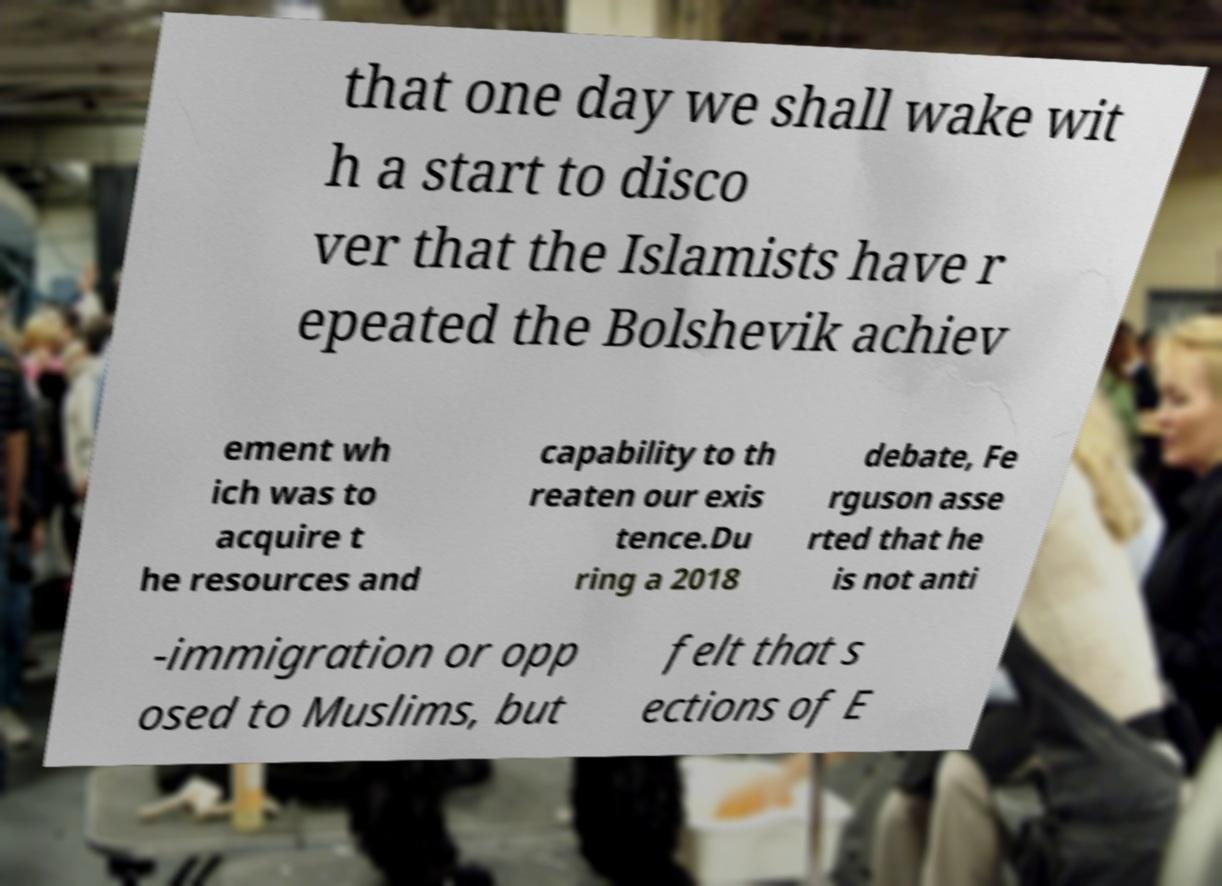Can you read and provide the text displayed in the image?This photo seems to have some interesting text. Can you extract and type it out for me? that one day we shall wake wit h a start to disco ver that the Islamists have r epeated the Bolshevik achiev ement wh ich was to acquire t he resources and capability to th reaten our exis tence.Du ring a 2018 debate, Fe rguson asse rted that he is not anti -immigration or opp osed to Muslims, but felt that s ections of E 